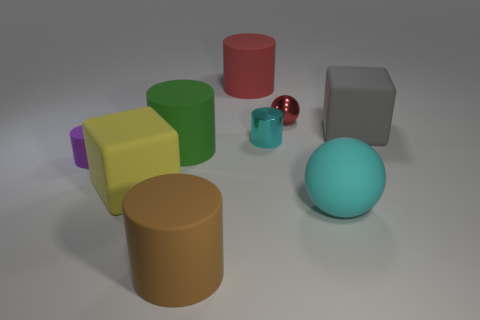Do the small cylinder that is to the left of the large brown rubber cylinder and the brown cylinder have the same material? Based on the image, it appears that both the small cylinder to the left of the large brown rubber-looking cylinder and the latter have a similar matte finish, which suggests they may be made of similar materials, such as a type of rubber or plastic with a non-glossy texture. However, without additional context or tactile inspection, we cannot conclusively determine the material composition solely from the visual information. 